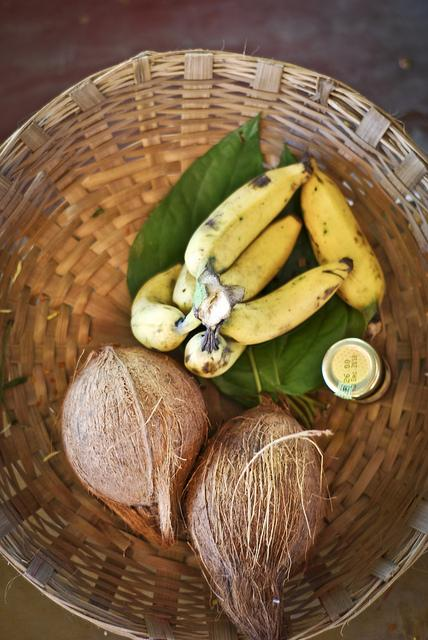What is the best climate for these fruits to grow in? tropical 